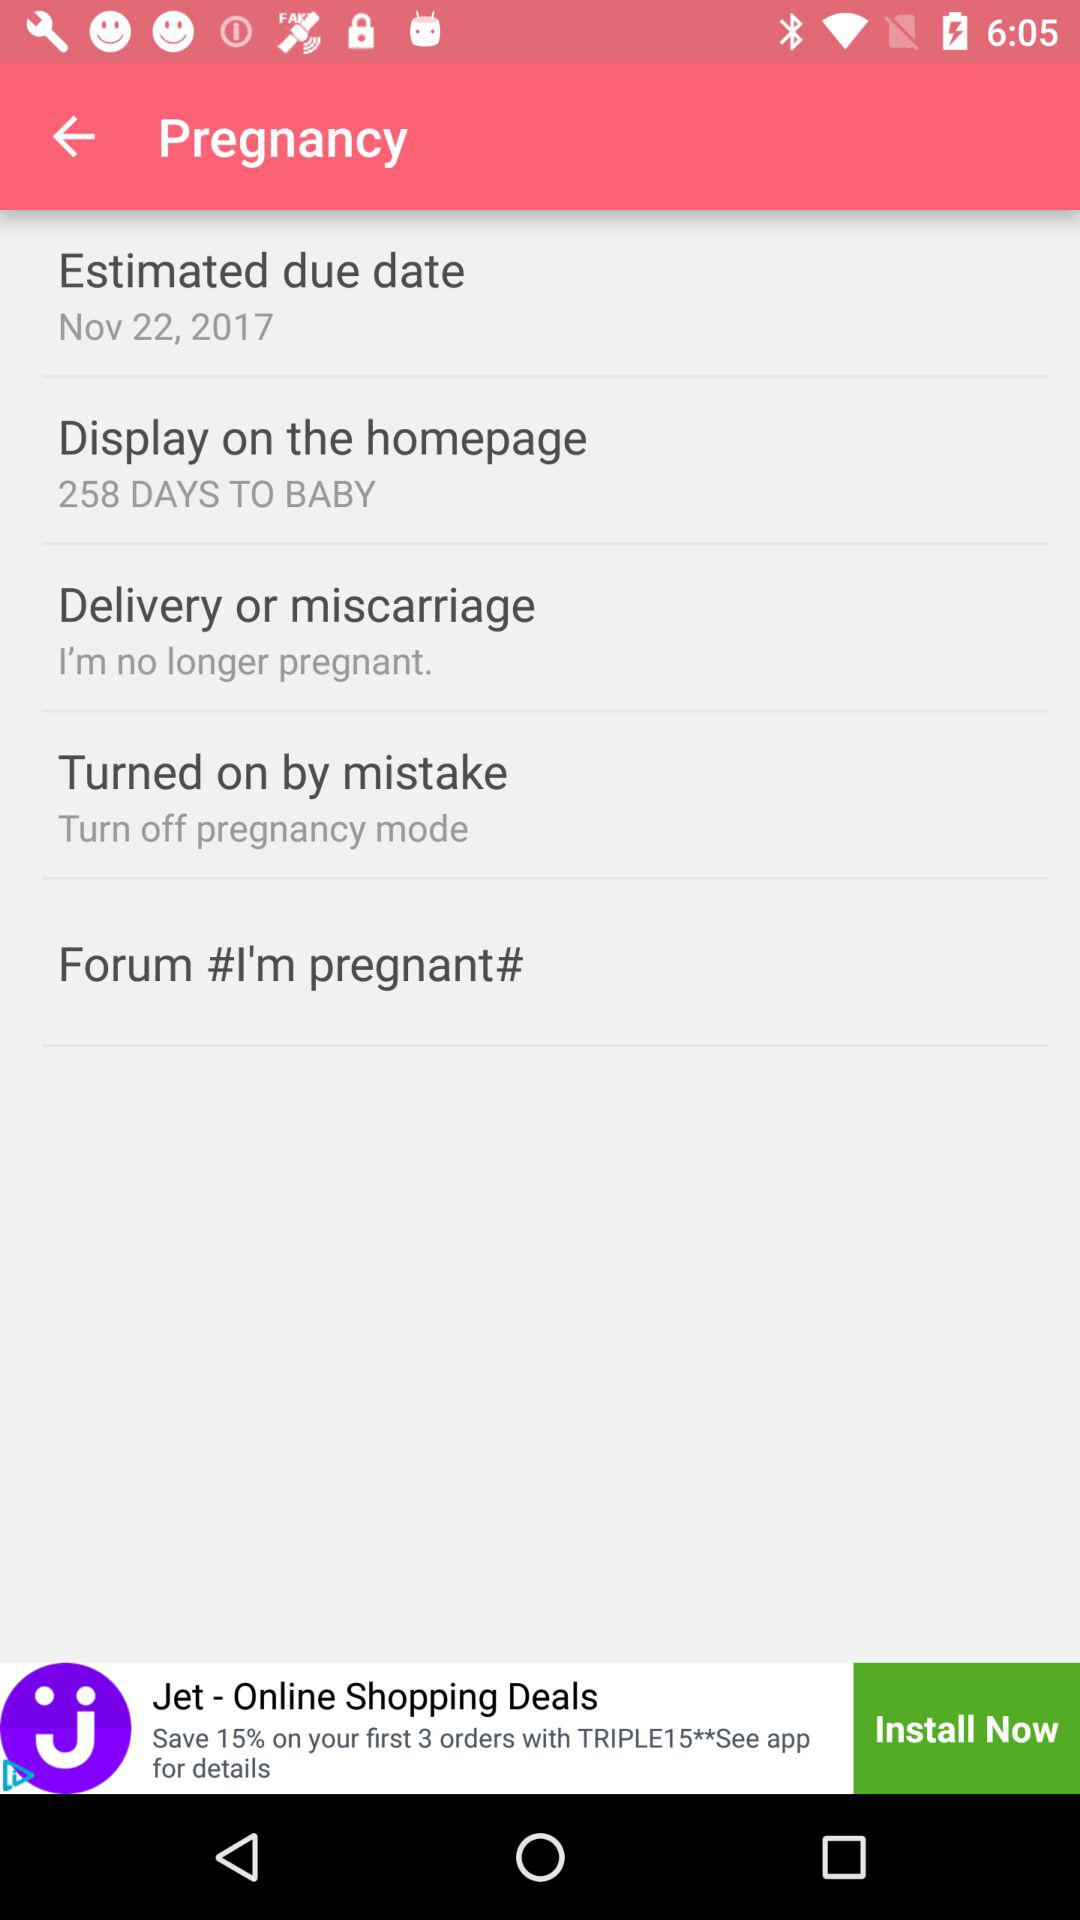What is the estimated due date? The date is November 22, 2017. 